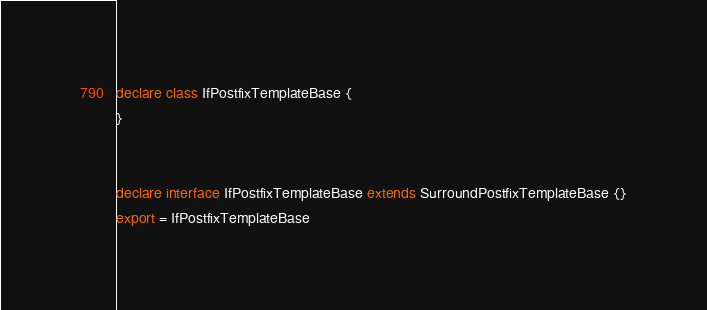Convert code to text. <code><loc_0><loc_0><loc_500><loc_500><_TypeScript_>declare class IfPostfixTemplateBase {
}


declare interface IfPostfixTemplateBase extends SurroundPostfixTemplateBase {}
export = IfPostfixTemplateBase
</code> 